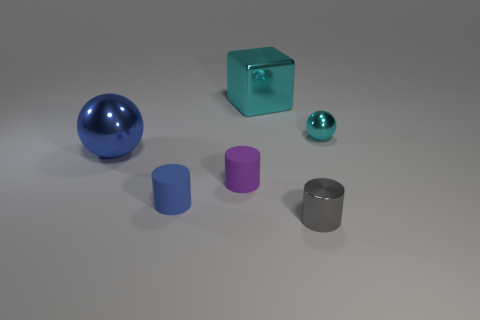Subtract all gray metal cylinders. How many cylinders are left? 2 Subtract all blue balls. How many balls are left? 1 Subtract all spheres. How many objects are left? 4 Add 1 tiny purple cylinders. How many objects exist? 7 Subtract 1 purple cylinders. How many objects are left? 5 Subtract all brown cubes. Subtract all green spheres. How many cubes are left? 1 Subtract all red spheres. How many brown cylinders are left? 0 Subtract all yellow cubes. Subtract all tiny metallic objects. How many objects are left? 4 Add 4 small cyan shiny objects. How many small cyan shiny objects are left? 5 Add 6 tiny gray metal spheres. How many tiny gray metal spheres exist? 6 